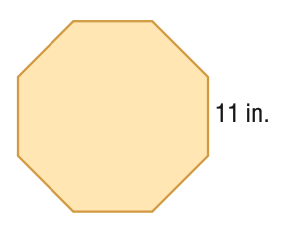Question: Find the area of the regular polygon. Round to the nearest tenth.
Choices:
A. 73.0
B. 292.1
C. 584.2
D. 1168.5
Answer with the letter. Answer: C 